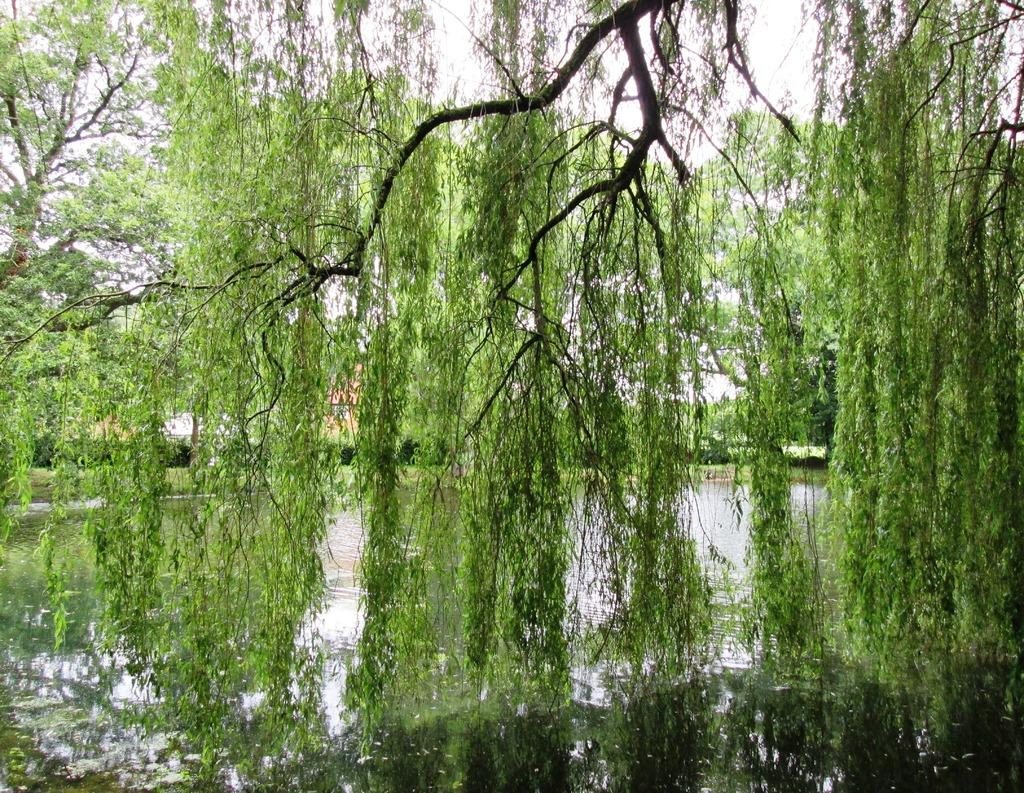What type of vegetation can be seen in the image? There are trees in the image. What natural element is visible in the image? There is water visible in the image. What level of cable is present in the image? There is no mention of a cable in the image, so it is not possible to determine the level of any cable. 